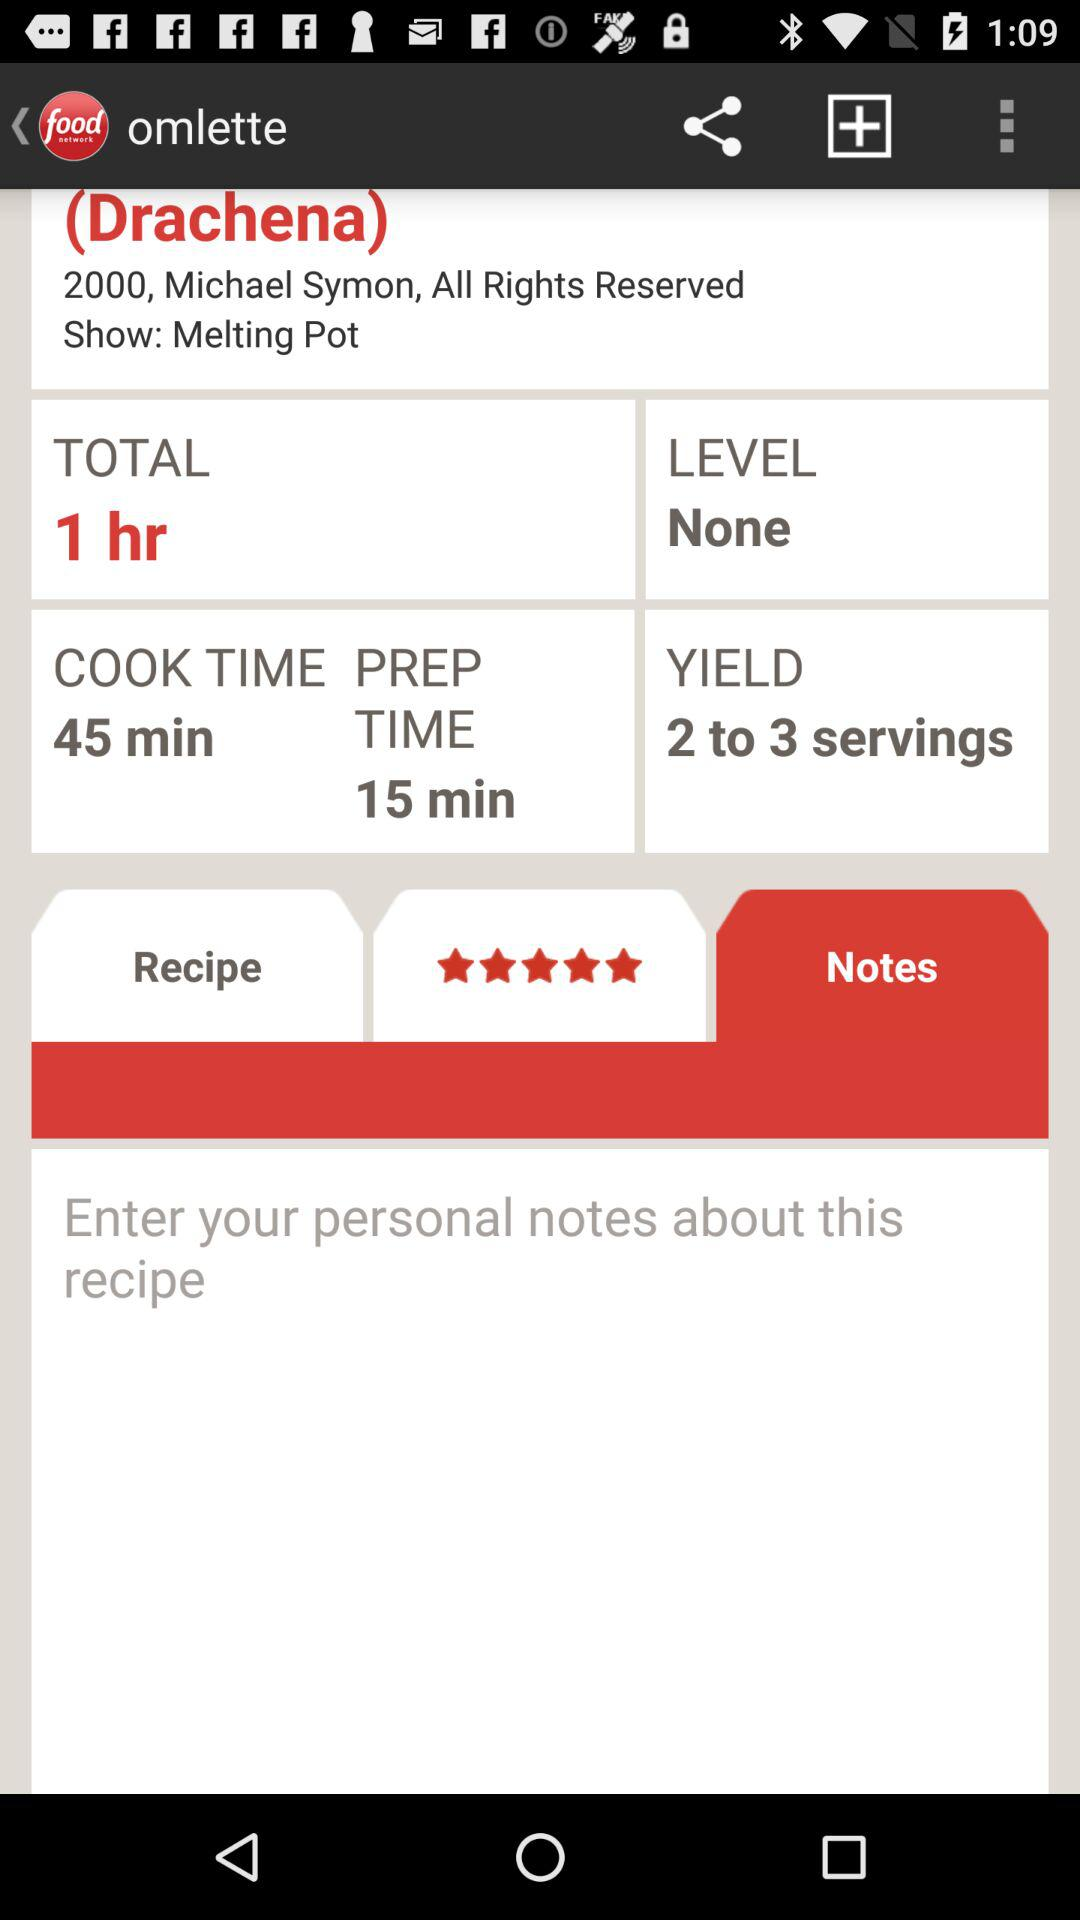How many more minutes is the cook time than the prep time?
Answer the question using a single word or phrase. 30 